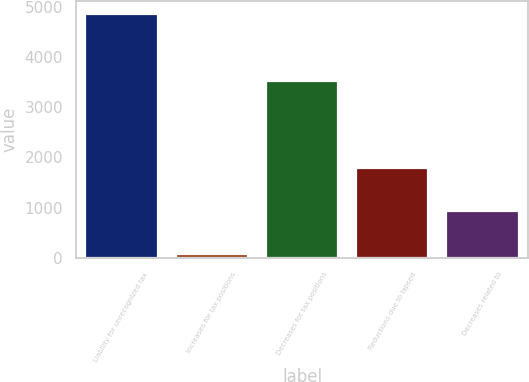Convert chart to OTSL. <chart><loc_0><loc_0><loc_500><loc_500><bar_chart><fcel>Liability for unrecognized tax<fcel>Increases for tax positions<fcel>Decreases for tax positions<fcel>Reductions due to lapsed<fcel>Decreases related to<nl><fcel>4862<fcel>80<fcel>3516<fcel>1779.8<fcel>929.9<nl></chart> 